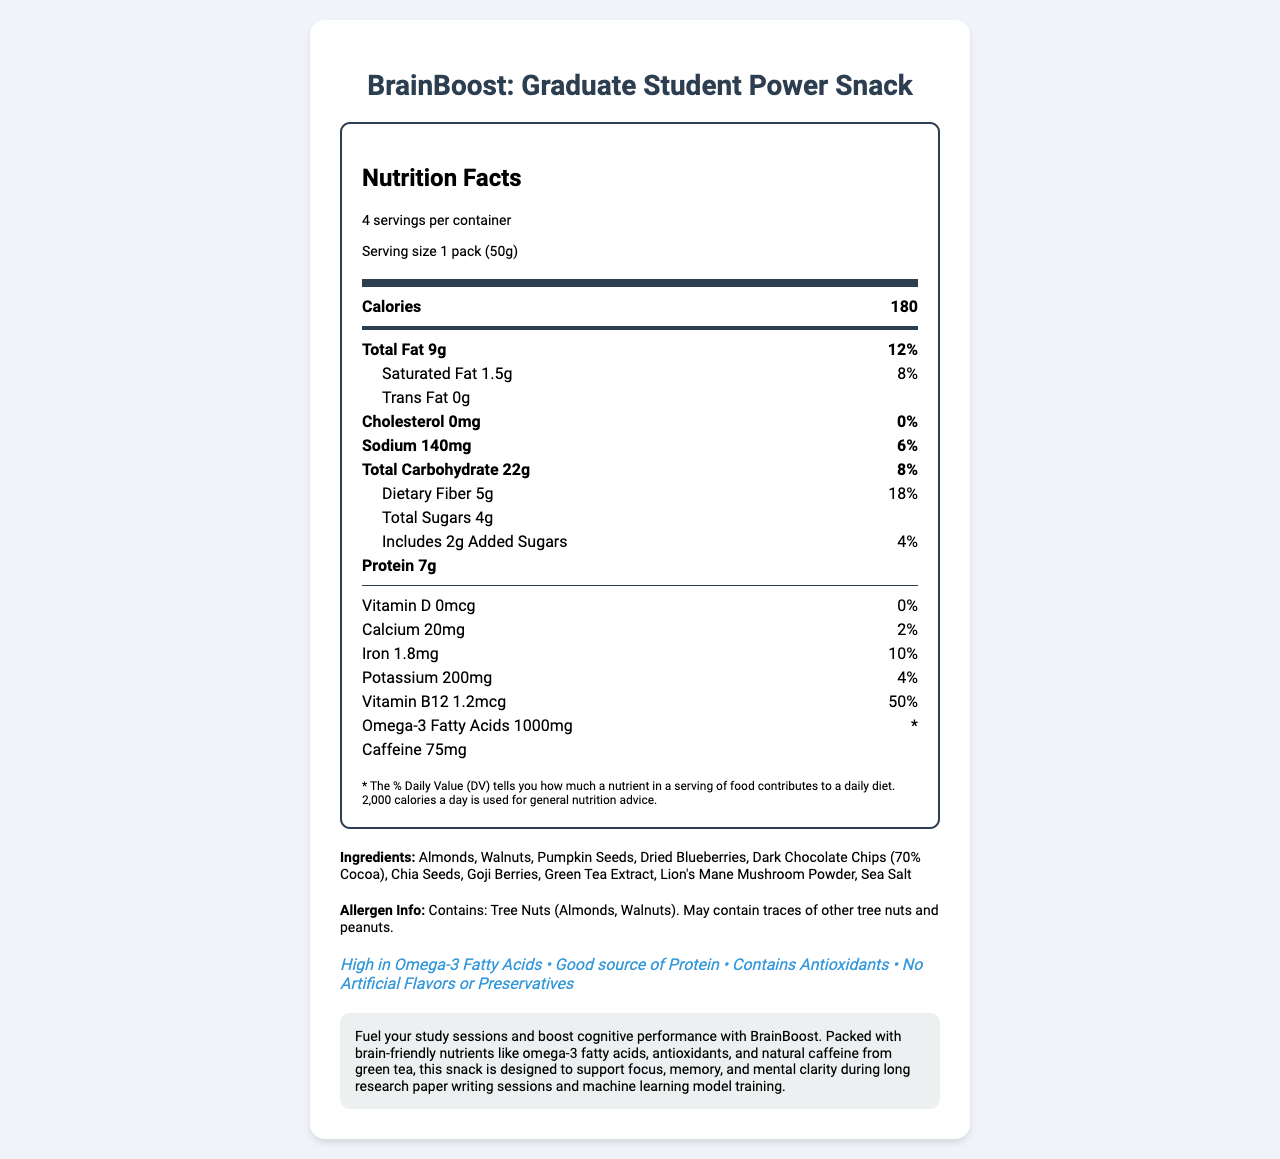what is the serving size? The serving size is listed at the top section of the nutrition label under the serving information.
Answer: 1 pack (50g) how many calories are in one serving? The number of calories per serving is found in the main section of the nutrition label.
Answer: 180 how many servings are in one container? This information is listed at the top section of the label under the serving information.
Answer: 4 what is the total fat content per serving? The total fat content is listed in the first nutrient row in the main section of the nutrition label.
Answer: 9g how many grams of dietary fiber are in one serving? The dietary fiber amount can be found within the "Total Carbohydrate" section of the nutrition label.
Answer: 5g which vitamin has the highest daily value percentage? A. Vitamin D B. Calcium C. Iron D. Vitamin B12 Vitamin B12 has a daily value percentage of 50%, which is the highest among the listed options.
Answer: D. Vitamin B12 how many added sugars are in one serving? A. 1g B. 2g C. 3g D. 4g The amount of added sugars is listed within the "Total Sugars" section and is specified as 2g.
Answer: B. 2g does the product contain any allergens? The nutrition label includes an allergen information section that states the product contains tree nuts (Almonds, Walnuts) and may contain traces of other tree nuts and peanuts.
Answer: Yes describe the main idea of the document. The document provides detailed nutritional information and highlights the brain-boosting benefits of the snack aimed at graduate students.
Answer: The document presents the nutrition facts, ingredients, and marketing description for "BrainBoost: Graduate Student Power Snack". It lists nutrient quantities, serving size, ingredients, allergen information, and health claims. The product is designed to support cognitive performance with ingredients like omega-3 fatty acids, antioxidants, and natural caffeine. is there any cholesterol in this product? The document lists cholesterol as 0mg with a daily value percentage of 0%.
Answer: No how much caffeine does one serving contain? The caffeine content per serving is provided at the bottom section of the nutrition label.
Answer: 75mg are there any artificial flavors or preservatives in this product? The marketing section includes a claim that the product contains no artificial flavors or preservatives.
Answer: No why might this product be beneficial for graduate students? The marketing description highlights the cognitive benefits, listing nutrients known for enhancing brain function.
Answer: The product supports cognitive performance during study sessions and research activities. It's rich in brain-friendly nutrients like omega-3 fatty acids, antioxidants, and natural caffeine, which help with focus, memory, and mental clarity. what is the percentage daily value of iron? The daily value percentage for iron is listed within the nutrient table.
Answer: 10% does the product contain artificial sweeteners? The document does not provide specific information about the presence or absence of artificial sweeteners. It only claims no artificial flavors or preservatives.
Answer: Cannot be determined is the omega-3 fatty acids daily value percentage provided? The document includes the amount of omega-3 fatty acids but does not provide the daily value percentage, marked with an asterisk.
Answer: No 